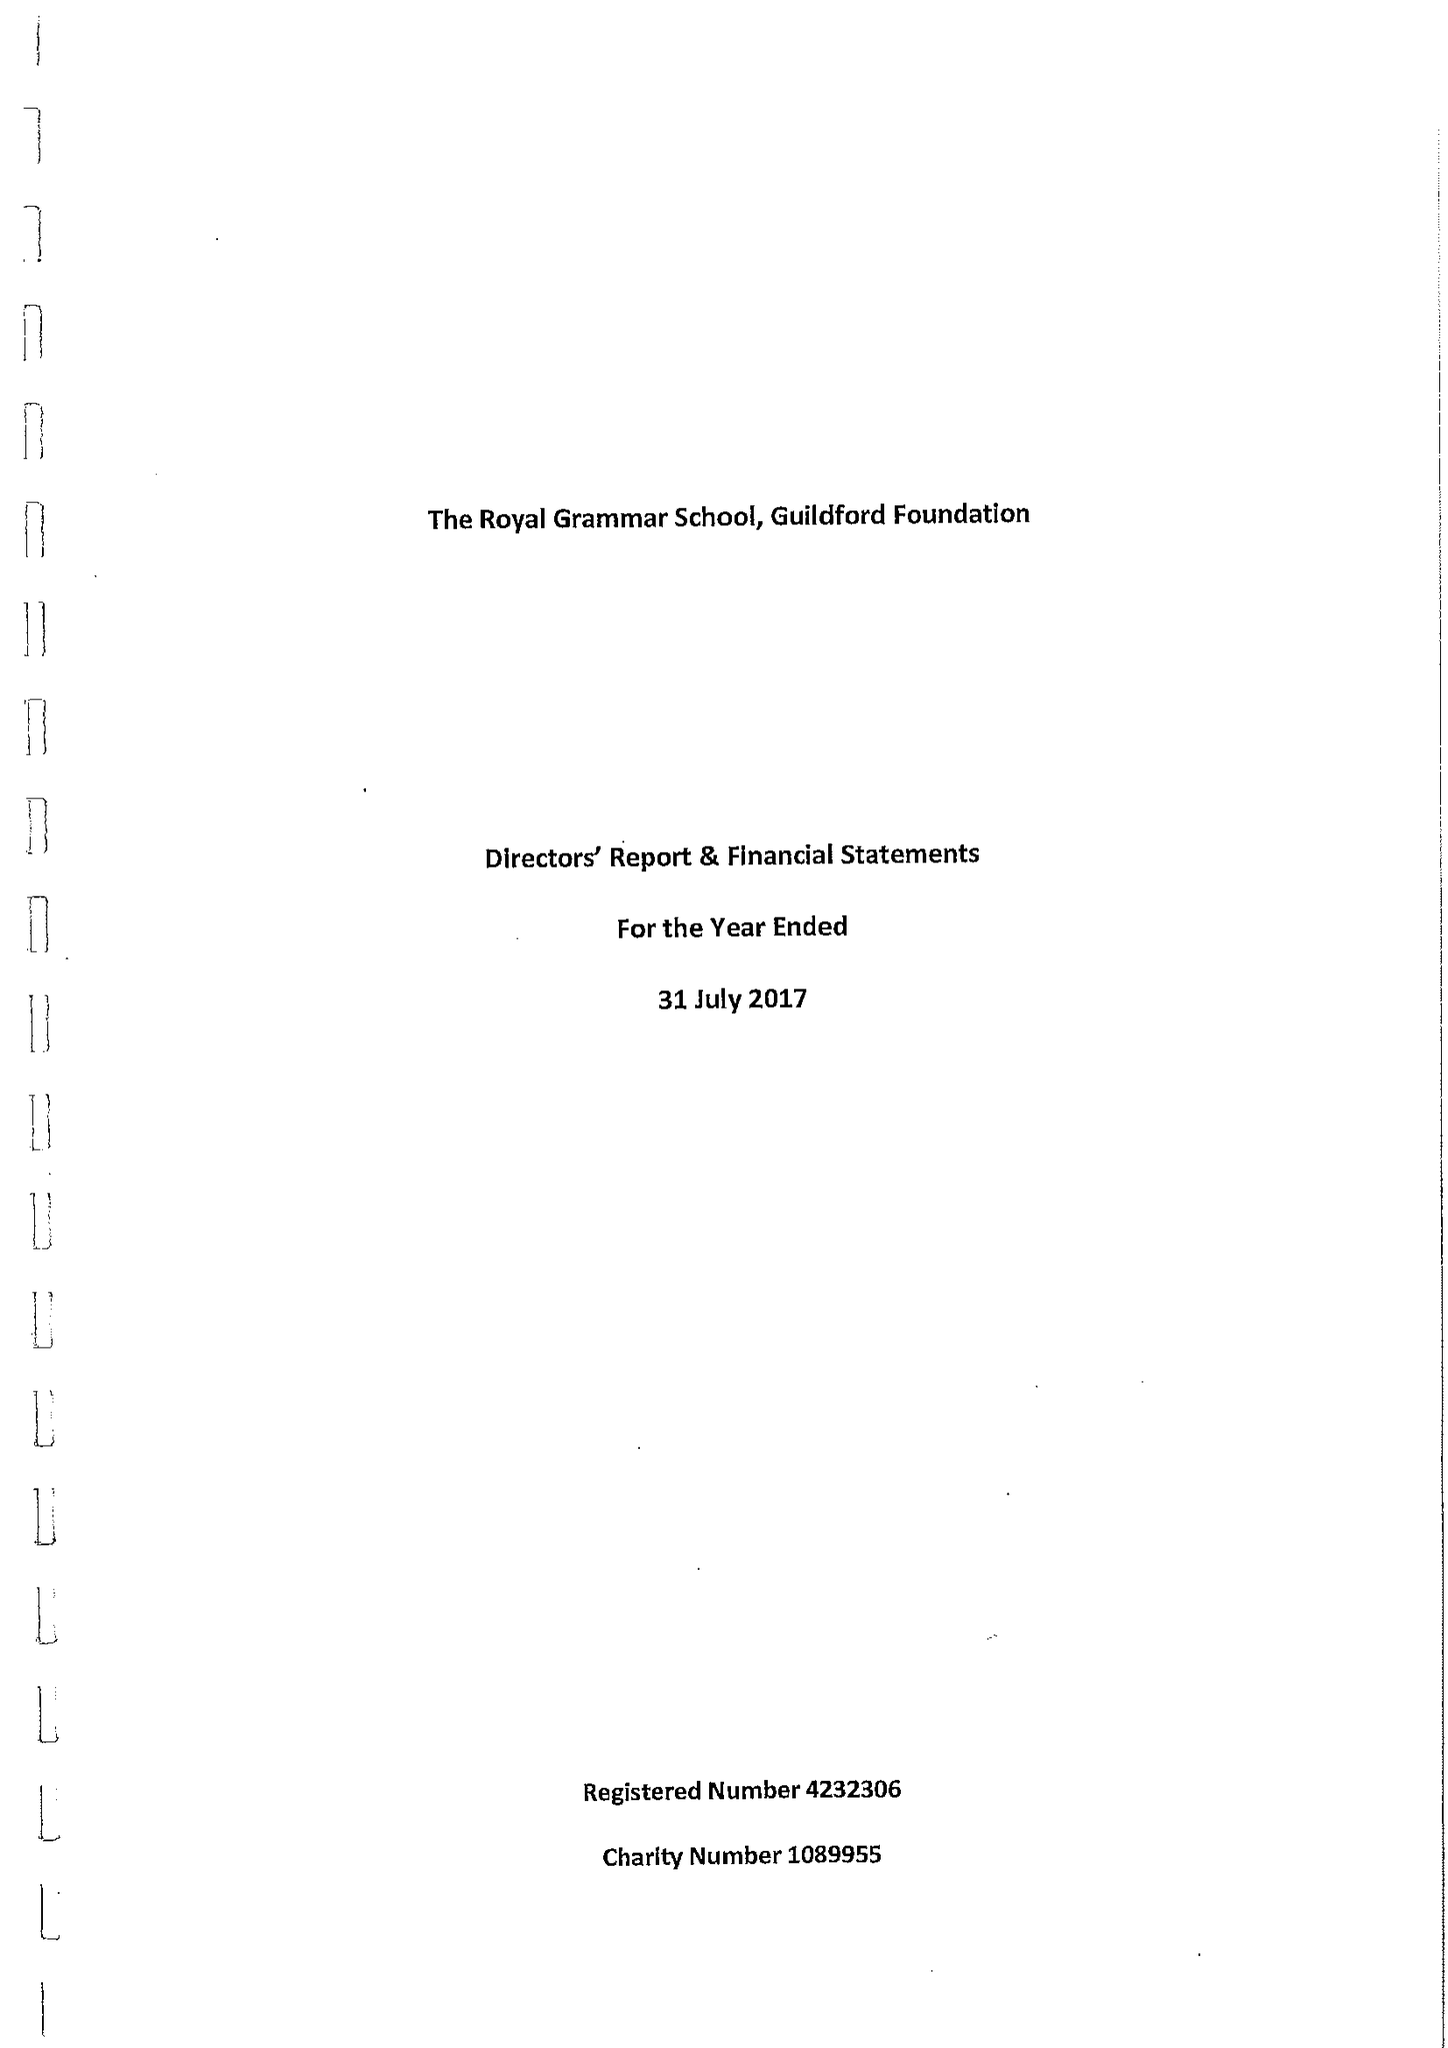What is the value for the charity_number?
Answer the question using a single word or phrase. 1089955 